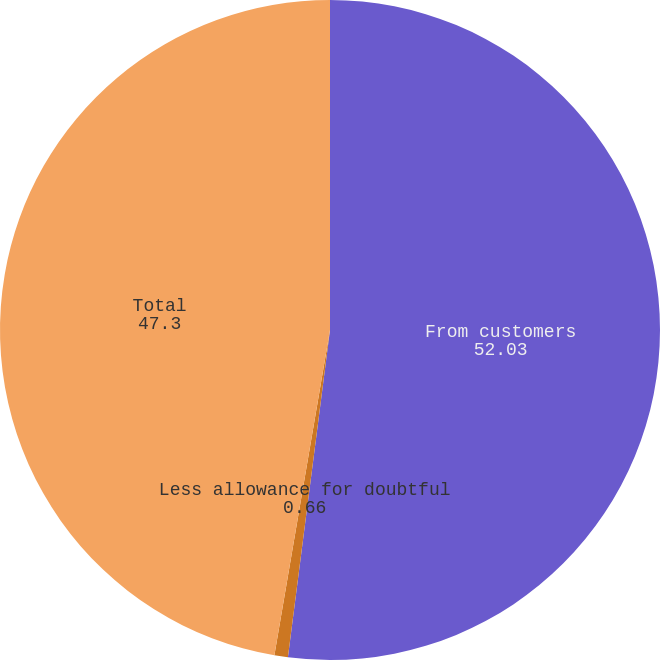<chart> <loc_0><loc_0><loc_500><loc_500><pie_chart><fcel>From customers<fcel>Less allowance for doubtful<fcel>Total<nl><fcel>52.03%<fcel>0.66%<fcel>47.3%<nl></chart> 